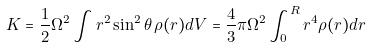Convert formula to latex. <formula><loc_0><loc_0><loc_500><loc_500>K = \frac { 1 } { 2 } \Omega ^ { 2 } \int r ^ { 2 } \sin ^ { 2 } \theta \, \rho ( r ) d V = \frac { 4 } { 3 } \pi \Omega ^ { 2 } \int _ { 0 } ^ { R } r ^ { 4 } \rho ( r ) d r</formula> 